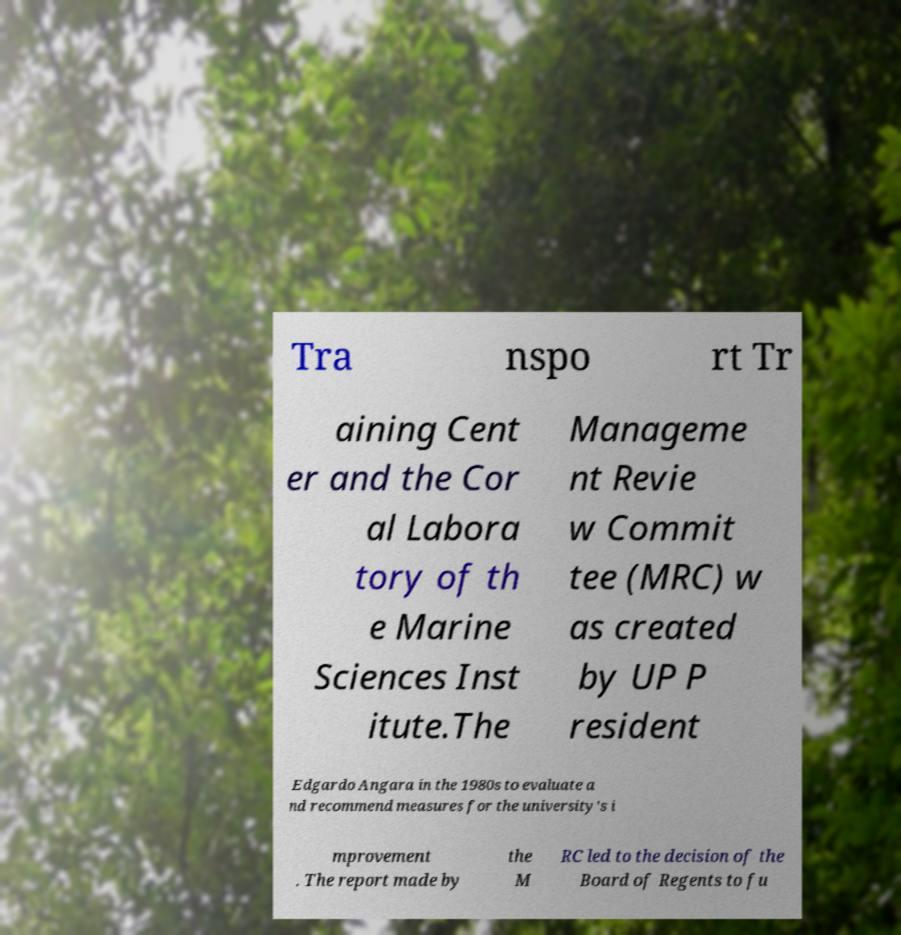Can you accurately transcribe the text from the provided image for me? Tra nspo rt Tr aining Cent er and the Cor al Labora tory of th e Marine Sciences Inst itute.The Manageme nt Revie w Commit tee (MRC) w as created by UP P resident Edgardo Angara in the 1980s to evaluate a nd recommend measures for the university's i mprovement . The report made by the M RC led to the decision of the Board of Regents to fu 